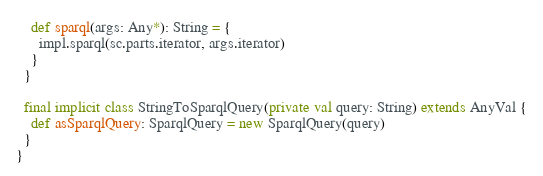<code> <loc_0><loc_0><loc_500><loc_500><_Scala_>    def sparql(args: Any*): String = {
      impl.sparql(sc.parts.iterator, args.iterator)
    }
  }

  final implicit class StringToSparqlQuery(private val query: String) extends AnyVal {
    def asSparqlQuery: SparqlQuery = new SparqlQuery(query)
  }
}
</code> 